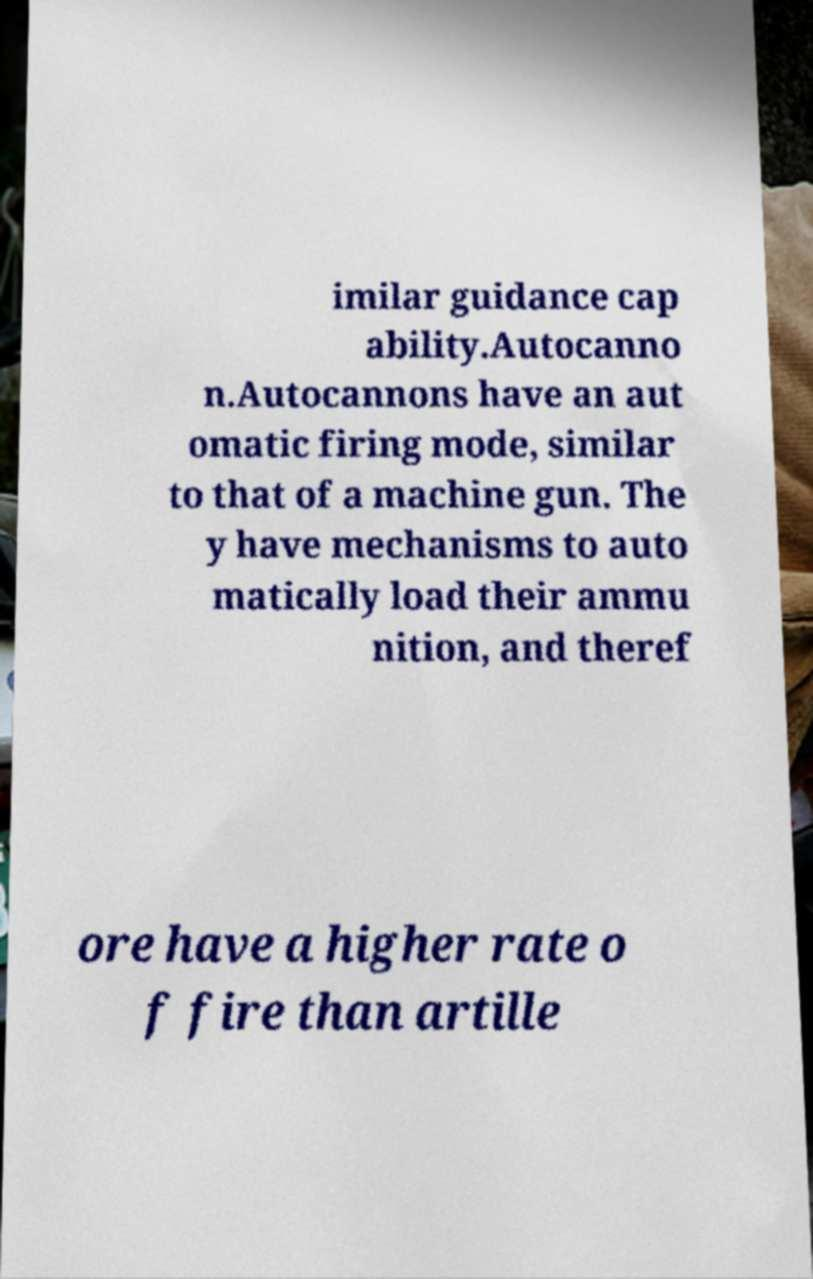For documentation purposes, I need the text within this image transcribed. Could you provide that? imilar guidance cap ability.Autocanno n.Autocannons have an aut omatic firing mode, similar to that of a machine gun. The y have mechanisms to auto matically load their ammu nition, and theref ore have a higher rate o f fire than artille 